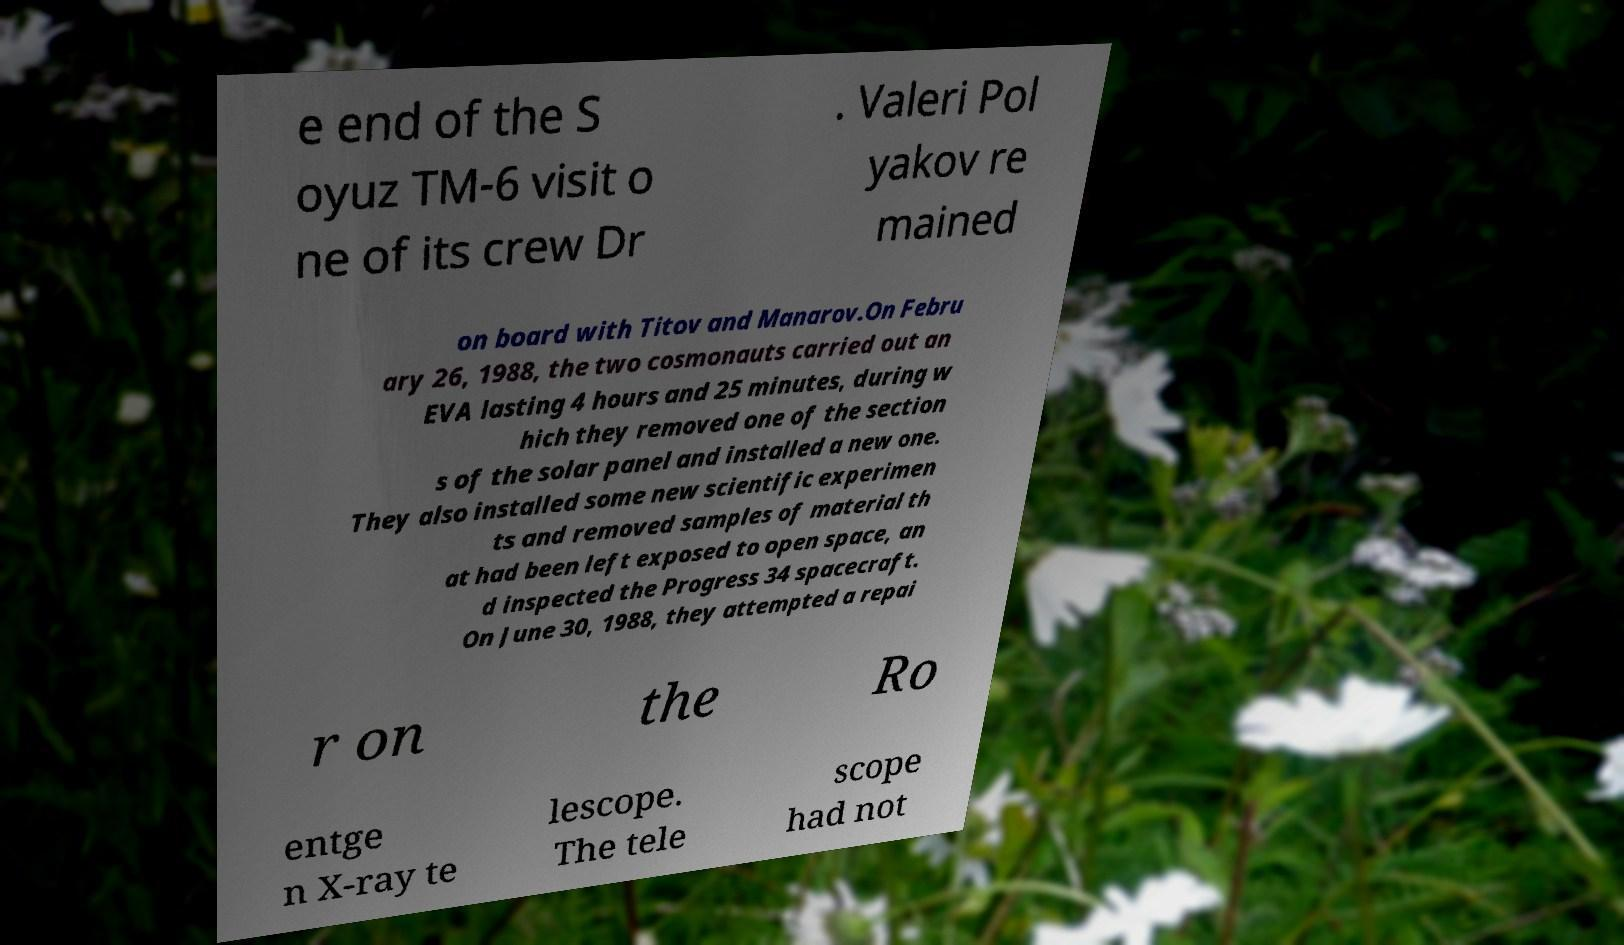Could you assist in decoding the text presented in this image and type it out clearly? e end of the S oyuz TM-6 visit o ne of its crew Dr . Valeri Pol yakov re mained on board with Titov and Manarov.On Febru ary 26, 1988, the two cosmonauts carried out an EVA lasting 4 hours and 25 minutes, during w hich they removed one of the section s of the solar panel and installed a new one. They also installed some new scientific experimen ts and removed samples of material th at had been left exposed to open space, an d inspected the Progress 34 spacecraft. On June 30, 1988, they attempted a repai r on the Ro entge n X-ray te lescope. The tele scope had not 